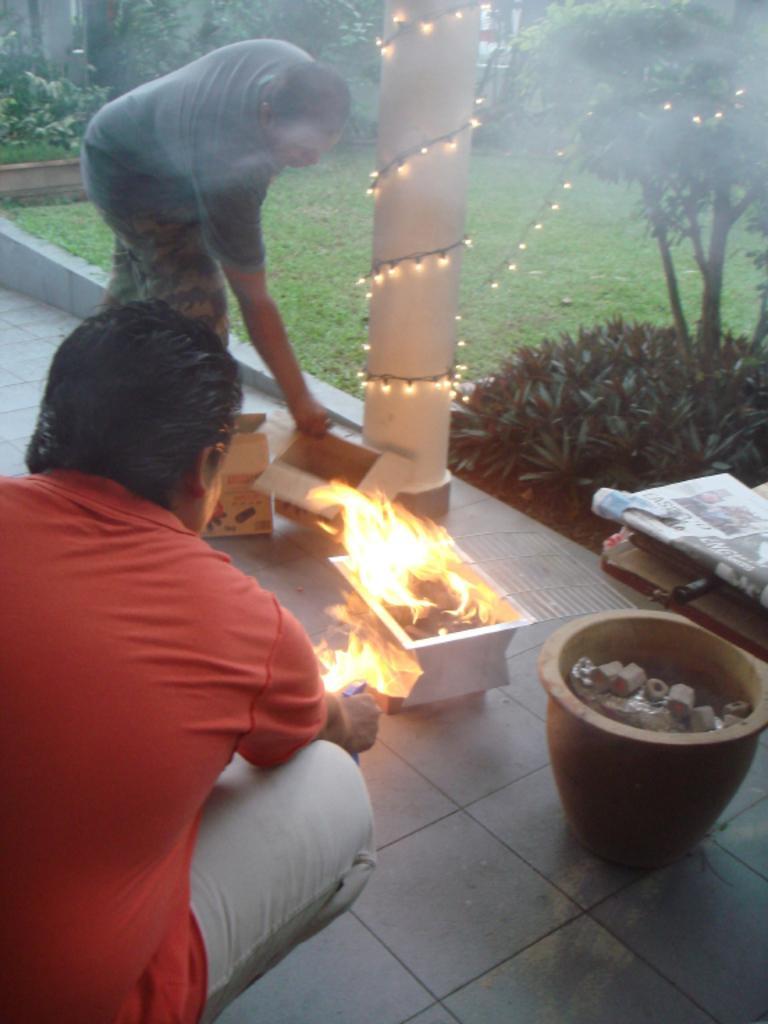How would you summarize this image in a sentence or two? In this image I can see two people one is sitting and the other is lying there are two paper cupboards one person is burning something and there is a pole in the center of the image with spiral lights and there are plants at the right bottom corner there is an earthen pot with some objects. 